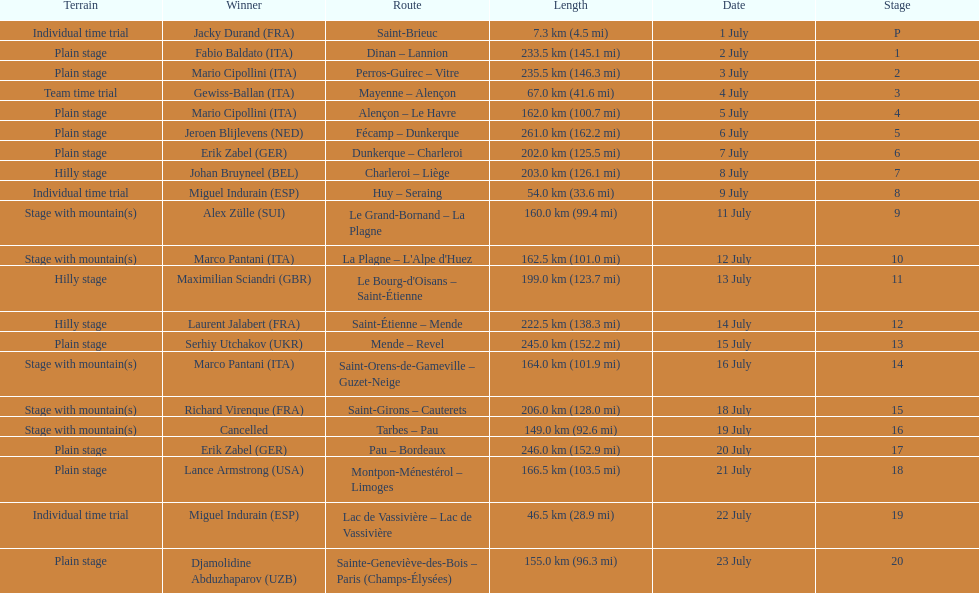How many consecutive km were raced on july 8th? 203.0 km (126.1 mi). 